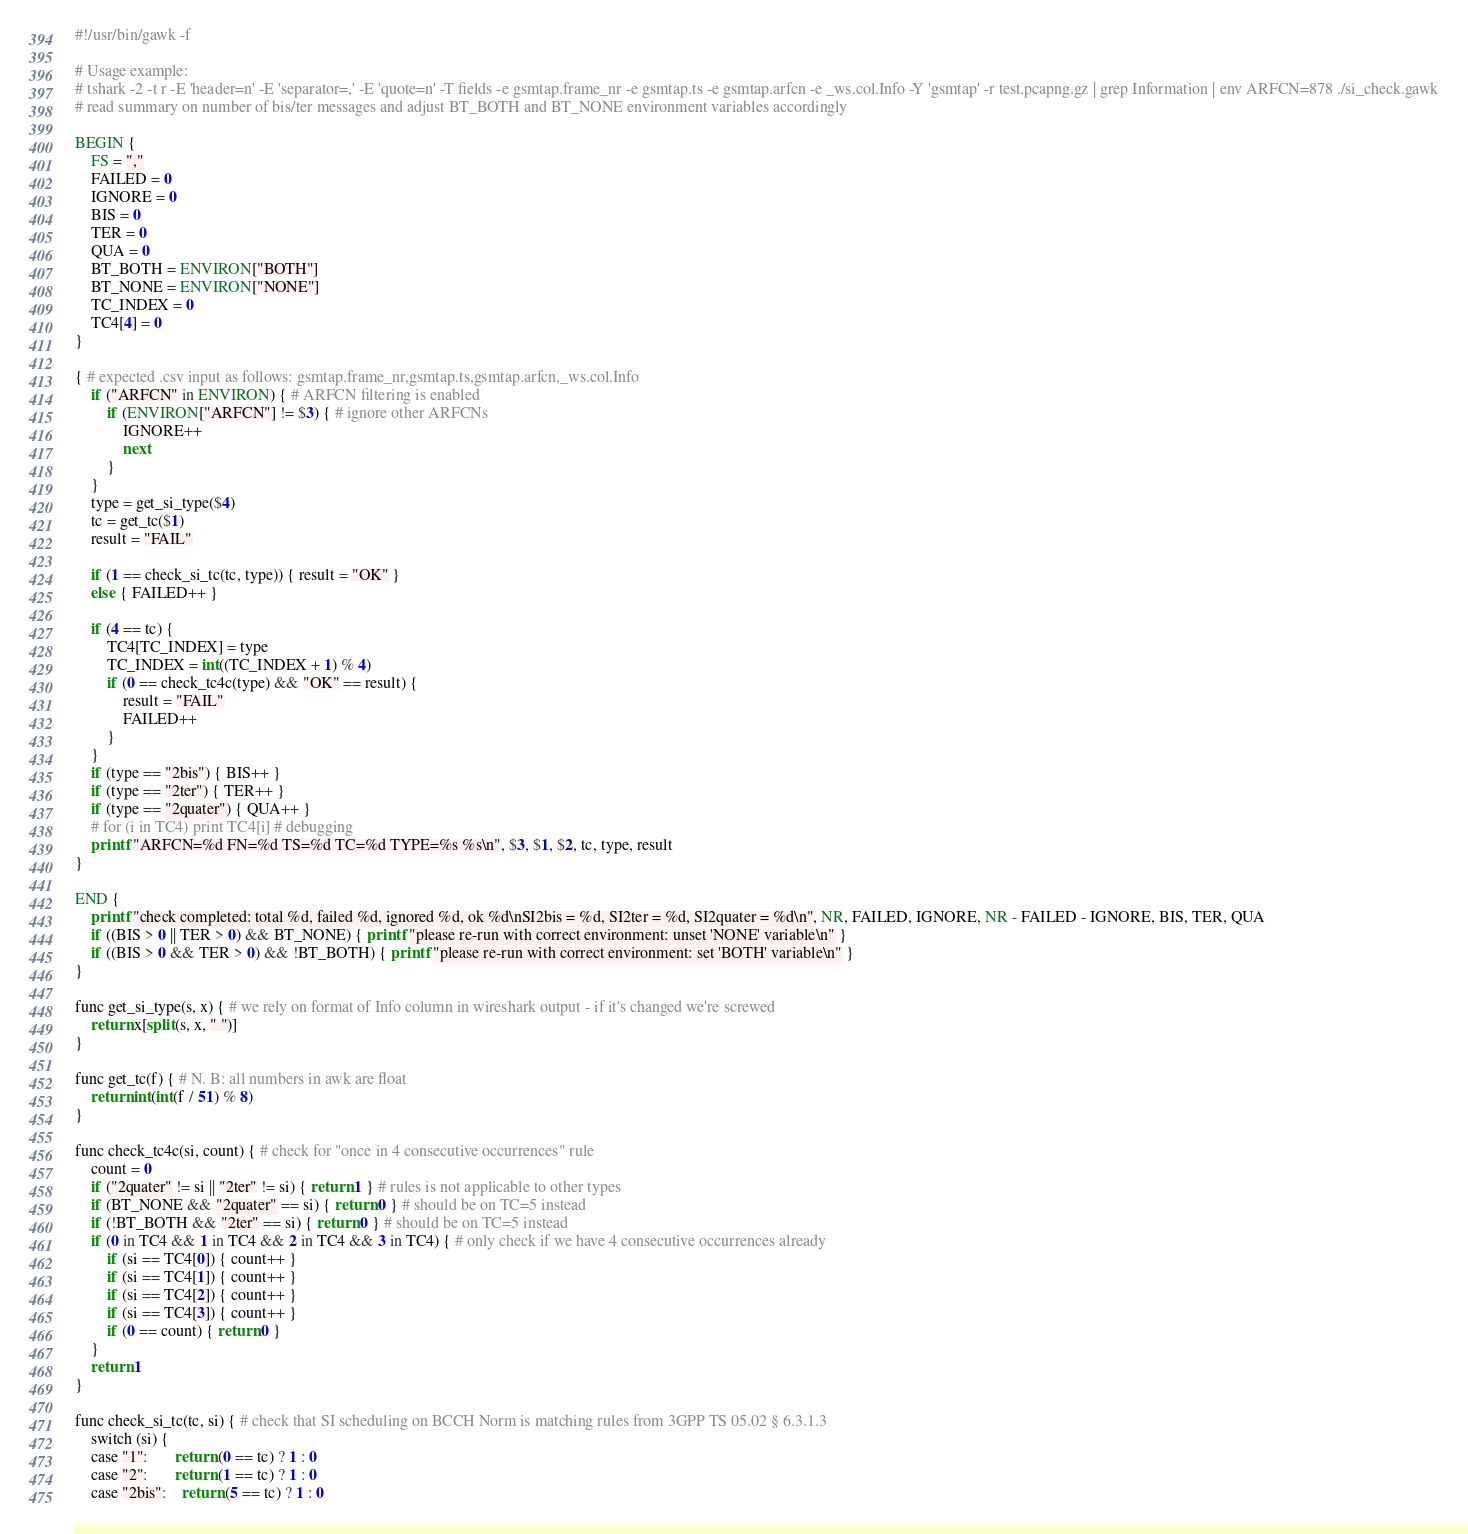<code> <loc_0><loc_0><loc_500><loc_500><_Awk_>#!/usr/bin/gawk -f

# Usage example:
# tshark -2 -t r -E 'header=n' -E 'separator=,' -E 'quote=n' -T fields -e gsmtap.frame_nr -e gsmtap.ts -e gsmtap.arfcn -e _ws.col.Info -Y 'gsmtap' -r test.pcapng.gz | grep Information | env ARFCN=878 ./si_check.gawk
# read summary on number of bis/ter messages and adjust BT_BOTH and BT_NONE environment variables accordingly

BEGIN {
	FS = ","
	FAILED = 0
	IGNORE = 0
	BIS = 0
	TER = 0
	QUA = 0
	BT_BOTH = ENVIRON["BOTH"]
	BT_NONE = ENVIRON["NONE"]
	TC_INDEX = 0
	TC4[4] = 0
}

{ # expected .csv input as follows: gsmtap.frame_nr,gsmtap.ts,gsmtap.arfcn,_ws.col.Info
	if ("ARFCN" in ENVIRON) { # ARFCN filtering is enabled
		if (ENVIRON["ARFCN"] != $3) { # ignore other ARFCNs
			IGNORE++
			next
		}
	}
	type = get_si_type($4)
	tc = get_tc($1)
	result = "FAIL"

	if (1 == check_si_tc(tc, type)) { result = "OK" }
	else { FAILED++ }

	if (4 == tc) {
		TC4[TC_INDEX] = type
		TC_INDEX = int((TC_INDEX + 1) % 4)
		if (0 == check_tc4c(type) && "OK" == result) {
			result = "FAIL"
			FAILED++
		}
	}
	if (type == "2bis") { BIS++ }
	if (type == "2ter") { TER++ }
	if (type == "2quater") { QUA++ }
	# for (i in TC4) print TC4[i] # debugging
	printf "ARFCN=%d FN=%d TS=%d TC=%d TYPE=%s %s\n", $3, $1, $2, tc, type, result
}

END {
	printf "check completed: total %d, failed %d, ignored %d, ok %d\nSI2bis = %d, SI2ter = %d, SI2quater = %d\n", NR, FAILED, IGNORE, NR - FAILED - IGNORE, BIS, TER, QUA
	if ((BIS > 0 || TER > 0) && BT_NONE) { printf "please re-run with correct environment: unset 'NONE' variable\n" }
	if ((BIS > 0 && TER > 0) && !BT_BOTH) { printf "please re-run with correct environment: set 'BOTH' variable\n" }
}

func get_si_type(s, x) { # we rely on format of Info column in wireshark output - if it's changed we're screwed
	return x[split(s, x, " ")]
}

func get_tc(f) { # N. B: all numbers in awk are float
	return int(int(f / 51) % 8)
}

func check_tc4c(si, count) { # check for "once in 4 consecutive occurrences" rule
	count = 0
	if ("2quater" != si || "2ter" != si) { return 1 } # rules is not applicable to other types
	if (BT_NONE && "2quater" == si) { return 0 } # should be on TC=5 instead
	if (!BT_BOTH && "2ter" == si) { return 0 } # should be on TC=5 instead
	if (0 in TC4 && 1 in TC4 && 2 in TC4 && 3 in TC4) { # only check if we have 4 consecutive occurrences already
		if (si == TC4[0]) { count++ }
		if (si == TC4[1]) { count++ }
		if (si == TC4[2]) { count++ }
		if (si == TC4[3]) { count++ }
		if (0 == count) { return 0 }
	}
	return 1
}

func check_si_tc(tc, si) { # check that SI scheduling on BCCH Norm is matching rules from 3GPP TS 05.02 § 6.3.1.3
	switch (si) {
	case "1":       return (0 == tc) ? 1 : 0
	case "2":       return (1 == tc) ? 1 : 0
	case "2bis":    return (5 == tc) ? 1 : 0</code> 